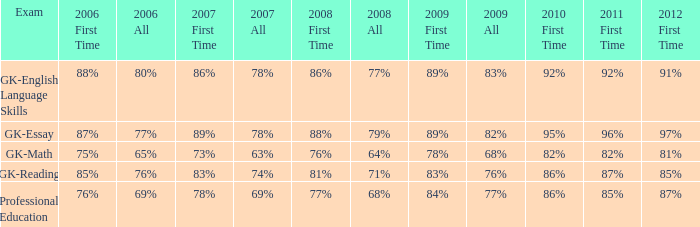What is the rate for all in 2007 when all in 2006 was 65%? 63%. 